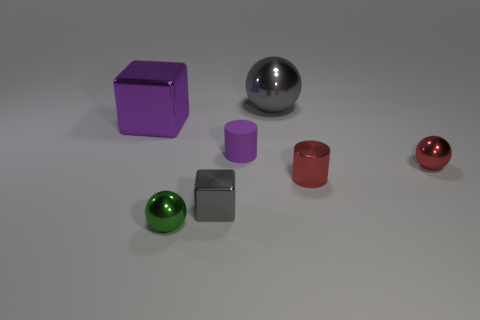Suppose you wanted to create a balanced arrangement with these objects, how would you reposition them? To create a visually balanced arrangement using these objects, I would place them symmetrically. For example, matching spheres of different colors on opposite sides and similarly positioning cylinders and cubes, ensuring that all items are evenly distributed across the space, creating aesthetic harmony. 